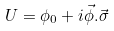Convert formula to latex. <formula><loc_0><loc_0><loc_500><loc_500>U = \phi _ { 0 } + i \vec { \phi } . \vec { \sigma }</formula> 